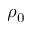Convert formula to latex. <formula><loc_0><loc_0><loc_500><loc_500>\rho _ { 0 }</formula> 